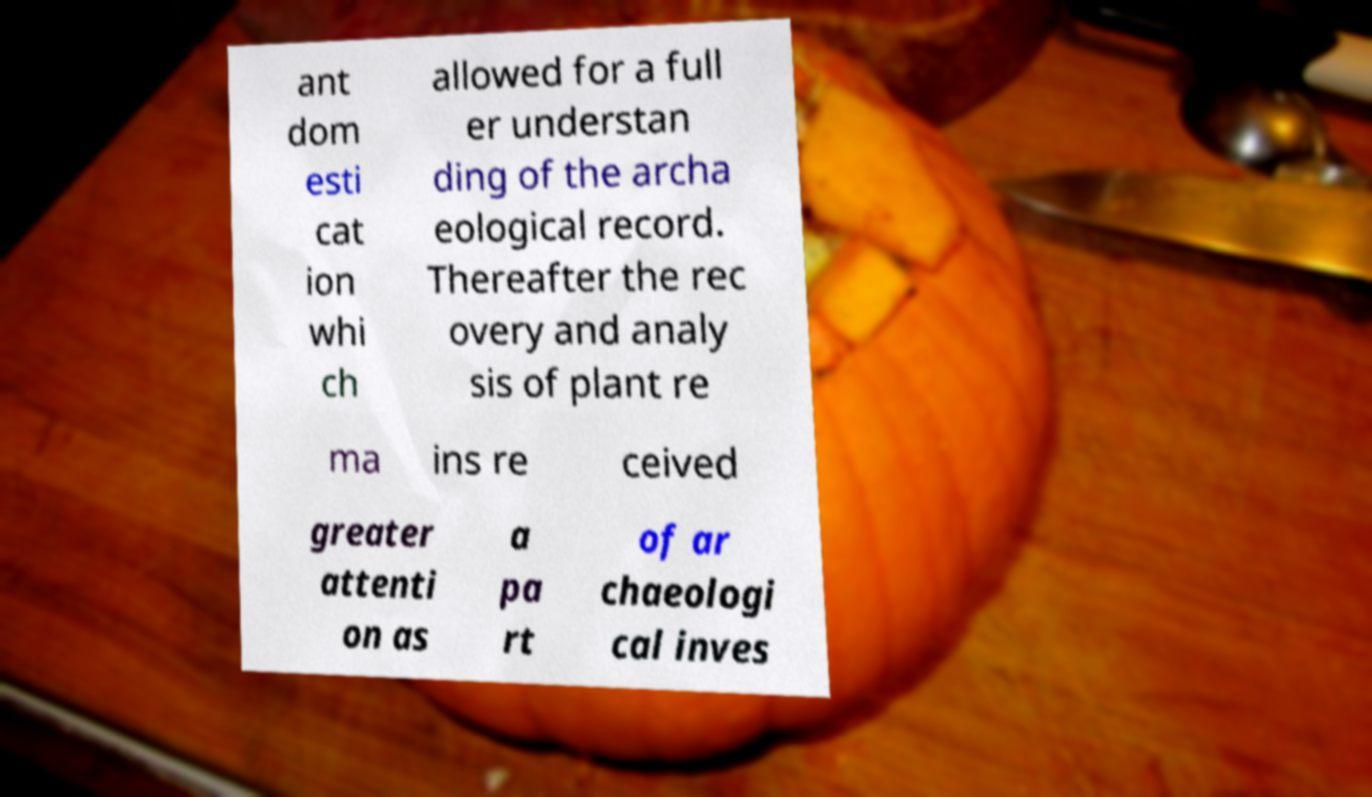I need the written content from this picture converted into text. Can you do that? ant dom esti cat ion whi ch allowed for a full er understan ding of the archa eological record. Thereafter the rec overy and analy sis of plant re ma ins re ceived greater attenti on as a pa rt of ar chaeologi cal inves 